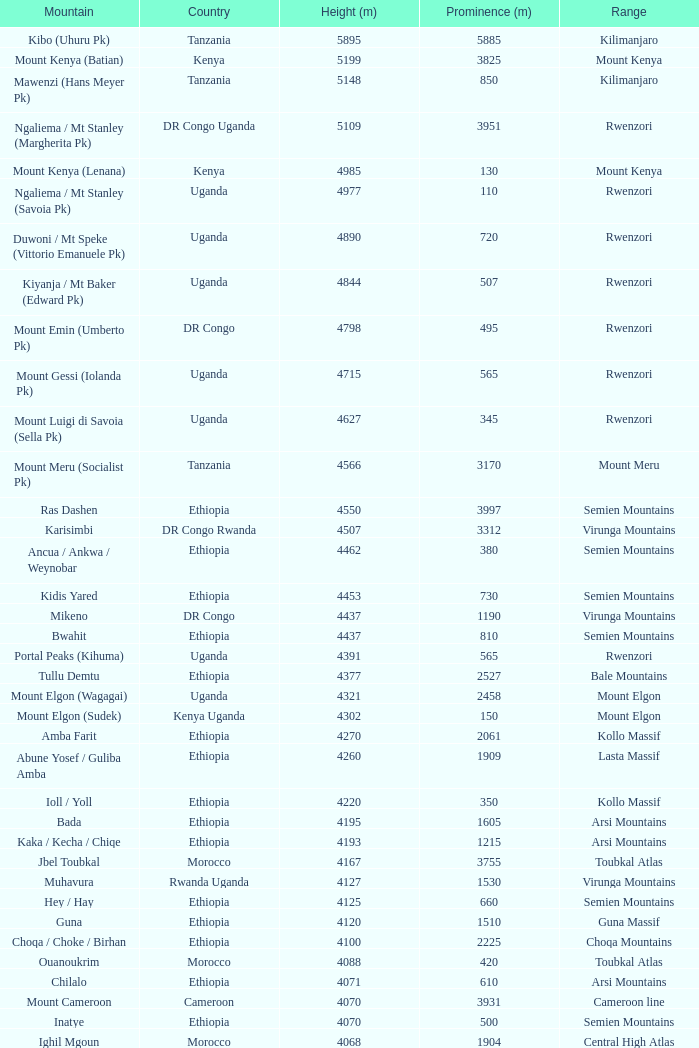Which Country has a Prominence (m) smaller than 1540, and a Height (m) smaller than 3530, and a Range of virunga mountains, and a Mountain of nyiragongo? DR Congo. Can you give me this table as a dict? {'header': ['Mountain', 'Country', 'Height (m)', 'Prominence (m)', 'Range'], 'rows': [['Kibo (Uhuru Pk)', 'Tanzania', '5895', '5885', 'Kilimanjaro'], ['Mount Kenya (Batian)', 'Kenya', '5199', '3825', 'Mount Kenya'], ['Mawenzi (Hans Meyer Pk)', 'Tanzania', '5148', '850', 'Kilimanjaro'], ['Ngaliema / Mt Stanley (Margherita Pk)', 'DR Congo Uganda', '5109', '3951', 'Rwenzori'], ['Mount Kenya (Lenana)', 'Kenya', '4985', '130', 'Mount Kenya'], ['Ngaliema / Mt Stanley (Savoia Pk)', 'Uganda', '4977', '110', 'Rwenzori'], ['Duwoni / Mt Speke (Vittorio Emanuele Pk)', 'Uganda', '4890', '720', 'Rwenzori'], ['Kiyanja / Mt Baker (Edward Pk)', 'Uganda', '4844', '507', 'Rwenzori'], ['Mount Emin (Umberto Pk)', 'DR Congo', '4798', '495', 'Rwenzori'], ['Mount Gessi (Iolanda Pk)', 'Uganda', '4715', '565', 'Rwenzori'], ['Mount Luigi di Savoia (Sella Pk)', 'Uganda', '4627', '345', 'Rwenzori'], ['Mount Meru (Socialist Pk)', 'Tanzania', '4566', '3170', 'Mount Meru'], ['Ras Dashen', 'Ethiopia', '4550', '3997', 'Semien Mountains'], ['Karisimbi', 'DR Congo Rwanda', '4507', '3312', 'Virunga Mountains'], ['Ancua / Ankwa / Weynobar', 'Ethiopia', '4462', '380', 'Semien Mountains'], ['Kidis Yared', 'Ethiopia', '4453', '730', 'Semien Mountains'], ['Mikeno', 'DR Congo', '4437', '1190', 'Virunga Mountains'], ['Bwahit', 'Ethiopia', '4437', '810', 'Semien Mountains'], ['Portal Peaks (Kihuma)', 'Uganda', '4391', '565', 'Rwenzori'], ['Tullu Demtu', 'Ethiopia', '4377', '2527', 'Bale Mountains'], ['Mount Elgon (Wagagai)', 'Uganda', '4321', '2458', 'Mount Elgon'], ['Mount Elgon (Sudek)', 'Kenya Uganda', '4302', '150', 'Mount Elgon'], ['Amba Farit', 'Ethiopia', '4270', '2061', 'Kollo Massif'], ['Abune Yosef / Guliba Amba', 'Ethiopia', '4260', '1909', 'Lasta Massif'], ['Ioll / Yoll', 'Ethiopia', '4220', '350', 'Kollo Massif'], ['Bada', 'Ethiopia', '4195', '1605', 'Arsi Mountains'], ['Kaka / Kecha / Chiqe', 'Ethiopia', '4193', '1215', 'Arsi Mountains'], ['Jbel Toubkal', 'Morocco', '4167', '3755', 'Toubkal Atlas'], ['Muhavura', 'Rwanda Uganda', '4127', '1530', 'Virunga Mountains'], ['Hey / Hay', 'Ethiopia', '4125', '660', 'Semien Mountains'], ['Guna', 'Ethiopia', '4120', '1510', 'Guna Massif'], ['Choqa / Choke / Birhan', 'Ethiopia', '4100', '2225', 'Choqa Mountains'], ['Ouanoukrim', 'Morocco', '4088', '420', 'Toubkal Atlas'], ['Chilalo', 'Ethiopia', '4071', '610', 'Arsi Mountains'], ['Mount Cameroon', 'Cameroon', '4070', '3931', 'Cameroon line'], ['Inatye', 'Ethiopia', '4070', '500', 'Semien Mountains'], ['Ighil Mgoun', 'Morocco', '4068', '1904', 'Central High Atlas'], ['Weshema / Wasema?', 'Ethiopia', '4030', '420', 'Bale Mountains'], ['Oldoinyo Lesatima', 'Kenya', '4001', '2081', 'Aberdare Range'], ["Jebel n'Tarourt / Tifnout / Iferouane", 'Morocco', '3996', '910', 'Toubkal Atlas'], ['Muggia', 'Ethiopia', '3950', '500', 'Lasta Massif'], ['Dubbai', 'Ethiopia', '3941', '1540', 'Tigray Mountains'], ['Taska n’Zat', 'Morocco', '3912', '460', 'Toubkal Atlas'], ['Aksouâl', 'Morocco', '3903', '450', 'Toubkal Atlas'], ['Mount Kinangop', 'Kenya', '3902', '530', 'Aberdare Range'], ['Cimbia', 'Ethiopia', '3900', '590', 'Kollo Massif'], ['Anrhemer / Ingehmar', 'Morocco', '3892', '380', 'Toubkal Atlas'], ['Ieciuol ?', 'Ethiopia', '3840', '560', 'Kollo Massif'], ['Kawa / Caua / Lajo', 'Ethiopia', '3830', '475', 'Bale Mountains'], ['Pt 3820', 'Ethiopia', '3820', '450', 'Kollo Massif'], ['Jbel Tignousti', 'Morocco', '3819', '930', 'Central High Atlas'], ['Filfo / Encuolo', 'Ethiopia', '3805', '770', 'Arsi Mountains'], ['Kosso Amba', 'Ethiopia', '3805', '530', 'Lasta Massif'], ['Jbel Ghat', 'Morocco', '3781', '470', 'Central High Atlas'], ['Baylamtu / Gavsigivla', 'Ethiopia', '3777', '1120', 'Lasta Massif'], ['Ouaougoulzat', 'Morocco', '3763', '860', 'Central High Atlas'], ['Somkaru', 'Ethiopia', '3760', '530', 'Bale Mountains'], ['Abieri', 'Ethiopia', '3750', '780', 'Semien Mountains'], ['Arin Ayachi', 'Morocco', '3747', '1400', 'East High Atlas'], ['Teide', 'Canary Islands', '3718', '3718', 'Tenerife'], ['Visoke / Bisoke', 'DR Congo Rwanda', '3711', '585', 'Virunga Mountains'], ['Sarenga', 'Ethiopia', '3700', '1160', 'Tigray Mountains'], ['Woti / Uoti', 'Ethiopia', '3700', '1050', 'Eastern Escarpment'], ['Pt 3700 (Kulsa?)', 'Ethiopia', '3700', '490', 'Arsi Mountains'], ['Loolmalassin', 'Tanzania', '3682', '2040', 'Crater Highlands'], ['Biala ?', 'Ethiopia', '3680', '870', 'Lasta Massif'], ['Azurki / Azourki', 'Morocco', '3677', '790', 'Central High Atlas'], ['Pt 3645', 'Ethiopia', '3645', '910', 'Lasta Massif'], ['Sabyinyo', 'Rwanda DR Congo Uganda', '3634', '1010', 'Virunga Mountains'], ['Mount Gurage / Guraghe', 'Ethiopia', '3620', '1400', 'Gurage Mountains'], ['Angour', 'Morocco', '3616', '444', 'Toubkal Atlas'], ['Jbel Igdat', 'Morocco', '3615', '1609', 'West High Atlas'], ["Jbel n'Anghomar", 'Morocco', '3609', '1420', 'Central High Atlas'], ['Yegura / Amba Moka', 'Ethiopia', '3605', '420', 'Lasta Massif'], ['Pt 3600 (Kitir?)', 'Ethiopia', '3600', '870', 'Eastern Escarpment'], ['Pt 3600', 'Ethiopia', '3600', '610', 'Lasta Massif'], ['Bar Meda high point', 'Ethiopia', '3580', '520', 'Eastern Escarpment'], ['Jbel Erdouz', 'Morocco', '3579', '690', 'West High Atlas'], ['Mount Gugu', 'Ethiopia', '3570', '940', 'Mount Gugu'], ['Gesh Megal (?)', 'Ethiopia', '3570', '520', 'Gurage Mountains'], ['Gughe', 'Ethiopia', '3568', '2013', 'Balta Mountains'], ['Megezez', 'Ethiopia', '3565', '690', 'Eastern Escarpment'], ['Pt 3555', 'Ethiopia', '3555', '475', 'Lasta Massif'], ['Jbel Tinergwet', 'Morocco', '3551', '880', 'West High Atlas'], ['Amba Alagi', 'Ethiopia', '3550', '820', 'Tigray Mountains'], ['Nakugen', 'Kenya', '3530', '1510', 'Cherangany Hills'], ['Gara Guda /Kara Gada', 'Ethiopia', '3530', '900', 'Salale Mountains'], ['Amonewas', 'Ethiopia', '3530', '870', 'Choqa Mountains'], ['Amedamit', 'Ethiopia', '3530', '760', 'Choqa Mountains'], ['Igoudamene', 'Morocco', '3519', '550', 'Central High Atlas'], ['Abuye Meda', 'Ethiopia', '3505', '230', 'Eastern Escarpment'], ['Thabana Ntlenyana', 'Lesotho', '3482', '2390', 'Drakensberg'], ['Mont Mohi', 'DR Congo', '3480', '1592', 'Mitumba Mountains'], ['Gahinga', 'Uganda Rwanda', '3474', '425', 'Virunga Mountains'], ['Nyiragongo', 'DR Congo', '3470', '1440', 'Virunga Mountains']]} 